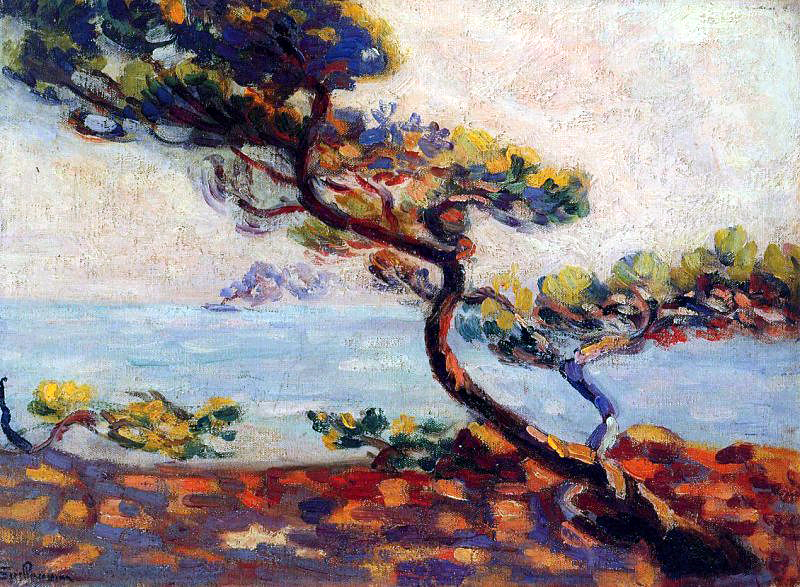What do the clouds in the background add to the overall composition? The fluffy white clouds in the background add a sense of depth and expansiveness to the overall composition. They contrast with the vibrant colors of the tree and rocky shore, creating a balanced and harmonious scene. The clouds also contribute to the serene and tranquil mood of the painting, enhancing the feeling of calmness and infinite space in the natural world depicted. 